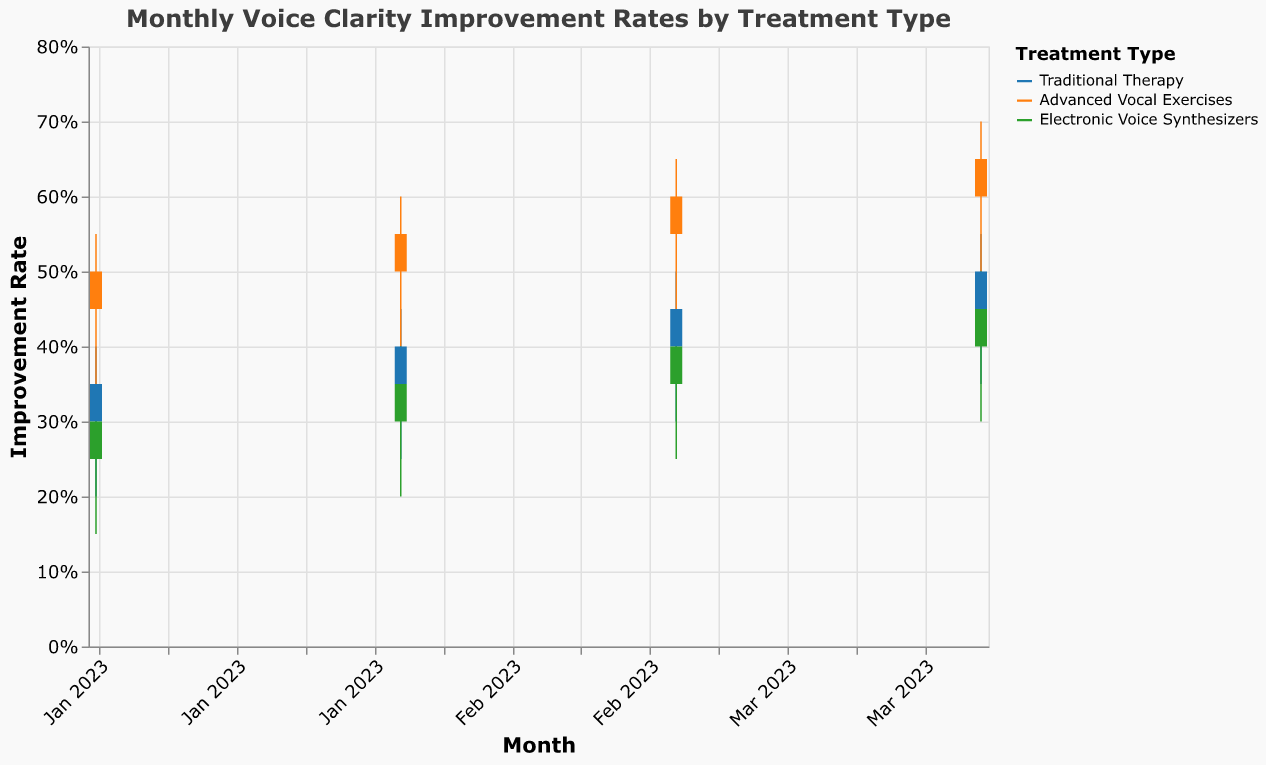What is the title of the plot? The title of the plot is located at the top and provides a description of what the chart is showing.
Answer: Monthly Voice Clarity Improvement Rates by Treatment Type Which treatment type shows the highest improvement rate in April 2023? Look for the month "2023-04" and compare the "Close" values for the different treatment types. The highest value here indicates the highest improvement rate.
Answer: Advanced Vocal Exercises What is the improvement rate range for Traditional Therapy in March 2023? For "2023-03" and "Traditional Therapy," examine the "High" and "Low" values. The range is between these two values.
Answer: 0.30 to 0.50 Which month observed the greatest fluctuation in improvement rates for Electronic Voice Synthesizers? For "Electronic Voice Synthesizers," calculate the difference between the "High" and "Low" values for each month, then determine which month has the largest difference.
Answer: 2023-04 How did the improvement rate for Traditional Therapy change from January to April 2023? Compare the "Close" values for "Traditional Therapy" from January (0.35) and April (0.50). The change is the difference between these values.
Answer: Increased by 0.15 What was the opening improvement rate for Advanced Vocal Exercises in March 2023? Look for the month "2023-03" and the treatment type "Advanced Vocal Exercises" then find the "Open" value.
Answer: 0.55 Which treatment type saw the least improvement rate in February 2023? For "2023-02," compare the "Close" values of all treatment types. The smallest value is the least improvement rate.
Answer: Electronic Voice Synthesizers How does the improvement rate of Traditional Therapy in January 2023 compare to that of Electronic Voice Synthesizers for the same month? For "2023-01," compare the "Close" values of "Traditional Therapy" (0.35) and "Electronic Voice Synthesizers" (0.30).
Answer: Traditional Therapy's improvement rate is higher by 0.05 What is the average closing improvement rate in January 2023 for all treatment types? Sum the "Close" values for all treatment types in "2023-01" and divide by the number of treatment types (3).
Answer: (0.35 + 0.50 + 0.30) / 3 = 0.3833 Is there a steady increase in the improvement rate for Advanced Vocal Exercises over the months? Compare the month-wise "Close" values for "Advanced Vocal Exercises" to see if each month's value is higher than the previous one.
Answer: Yes, the values increase each month 